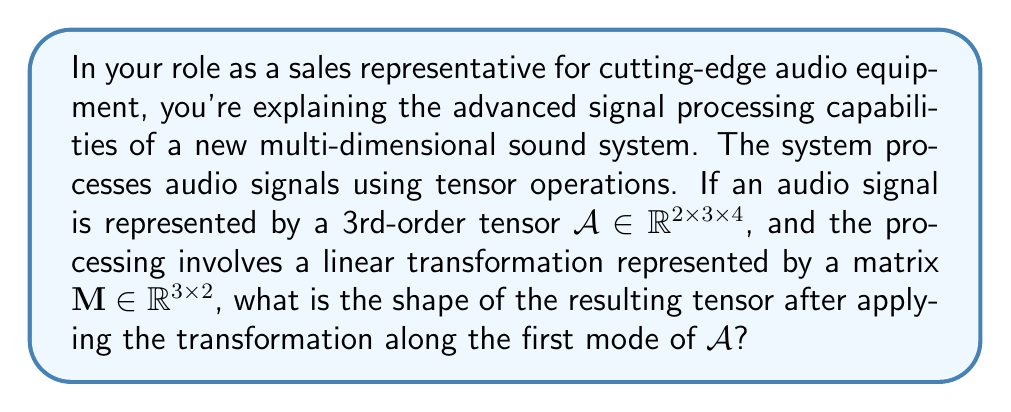Can you answer this question? To solve this problem, we need to understand tensor operations and mode-n products. Let's break it down step-by-step:

1) The initial audio signal is represented by a 3rd-order tensor $\mathcal{A} \in \mathbb{R}^{2 \times 3 \times 4}$. This means:
   - 1st mode (dimension) has size 2
   - 2nd mode has size 3
   - 3rd mode has size 4

2) The transformation matrix is $\mathbf{M} \in \mathbb{R}^{3 \times 2}$, which means it has 3 rows and 2 columns.

3) We're applying the transformation along the first mode of $\mathcal{A}$. In tensor operations, this is known as the mode-1 product.

4) The mode-1 product of a tensor $\mathcal{A}$ with a matrix $\mathbf{M}$ is denoted as $\mathcal{A} \times_1 \mathbf{M}$.

5) When we perform a mode-n product, the resulting tensor's shape changes in the following way:
   - The n-th mode of the tensor is replaced by the number of rows in the matrix
   - All other modes remain the same

6) In this case:
   - The 1st mode will change from 2 to 3 (number of rows in $\mathbf{M}$)
   - The 2nd and 3rd modes will remain 3 and 4 respectively

Therefore, the resulting tensor after the transformation will have the shape $3 \times 3 \times 4$.
Answer: $\mathbb{R}^{3 \times 3 \times 4}$ 